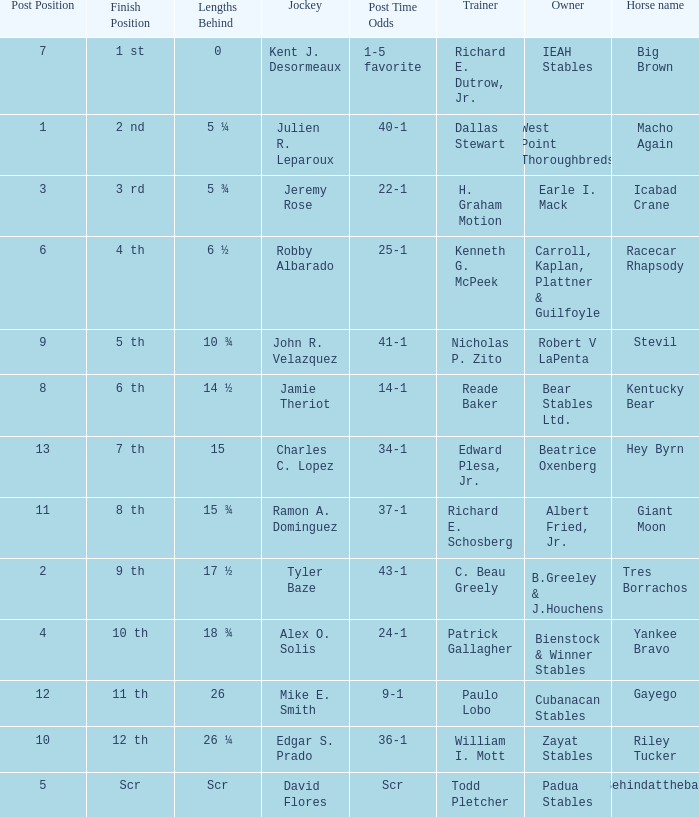Who is the owner of Icabad Crane? Earle I. Mack. 